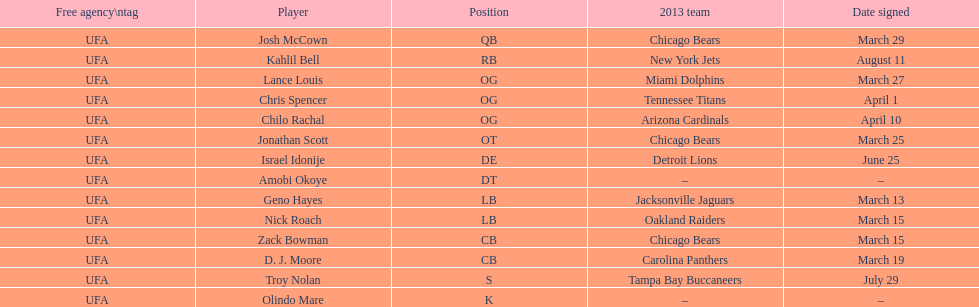Nick roach was signed the same day as what other player? Zack Bowman. 